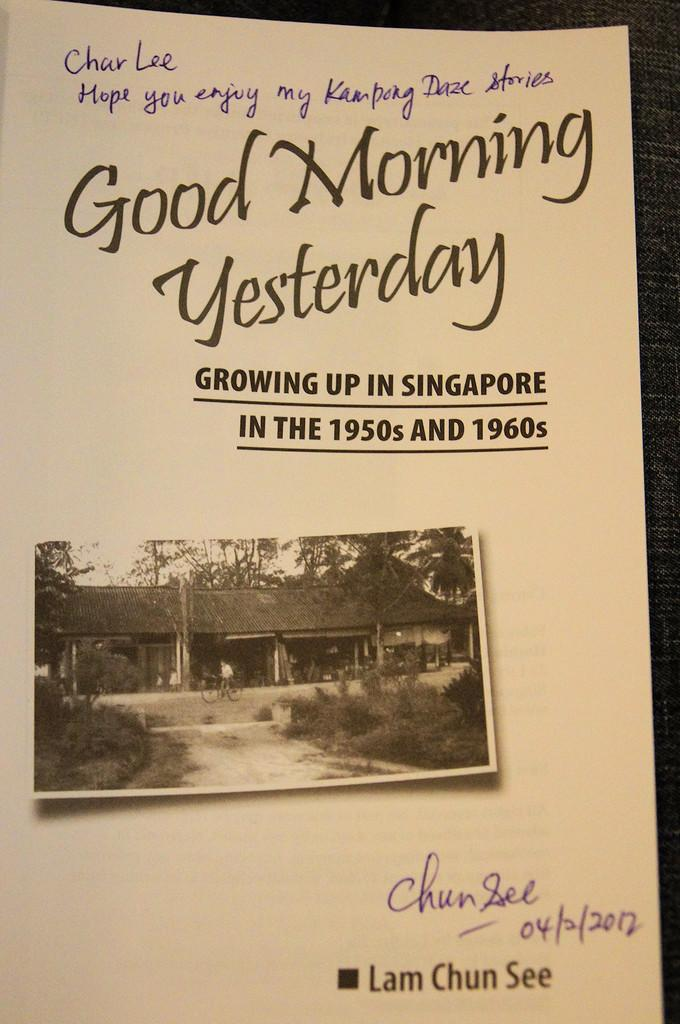Provide a one-sentence caption for the provided image. A book is open to the title page that says Good Morning Yesterday. 